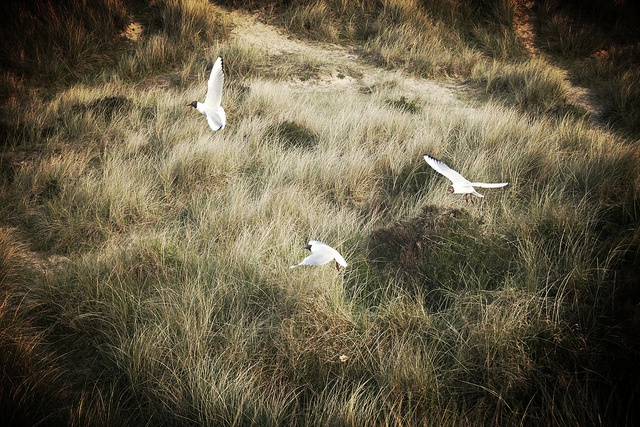Describe the objects in this image and their specific colors. I can see bird in black, white, darkgray, tan, and lightgray tones, bird in black, white, darkgray, and gray tones, and bird in black, white, darkgray, tan, and gray tones in this image. 